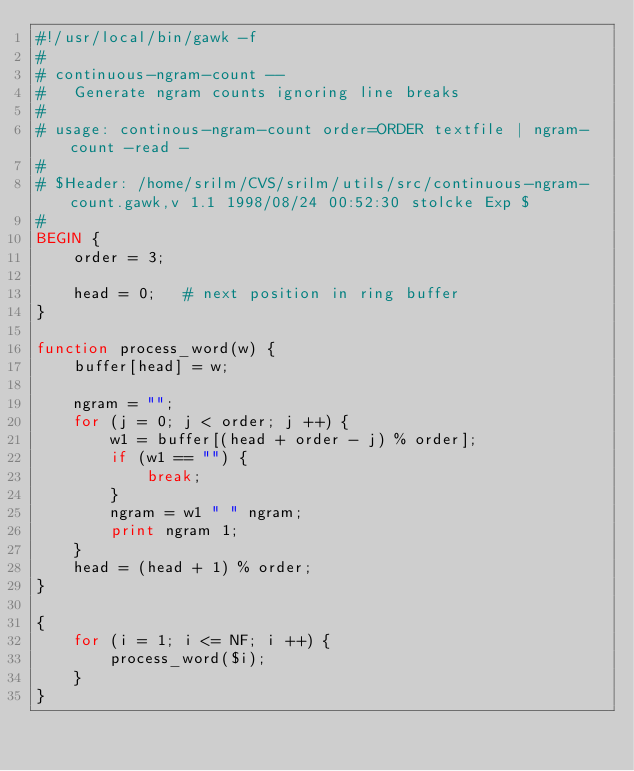Convert code to text. <code><loc_0><loc_0><loc_500><loc_500><_Awk_>#!/usr/local/bin/gawk -f
#
# continuous-ngram-count --
#	Generate ngram counts ignoring line breaks 
#	
# usage: continous-ngram-count order=ORDER textfile | ngram-count -read -
#
# $Header: /home/srilm/CVS/srilm/utils/src/continuous-ngram-count.gawk,v 1.1 1998/08/24 00:52:30 stolcke Exp $
#
BEGIN {
	order = 3;

	head = 0;	# next position in ring buffer
}

function process_word(w) {
	buffer[head] = w;

	ngram = "";
	for (j = 0; j < order; j ++) {
		w1 = buffer[(head + order - j) % order];
		if (w1 == "") {
			break;
		}
		ngram = w1 " " ngram;
		print ngram 1;
	}
	head = (head + 1) % order;
}

{
	for (i = 1; i <= NF; i ++) {
		process_word($i);
	}
}
</code> 